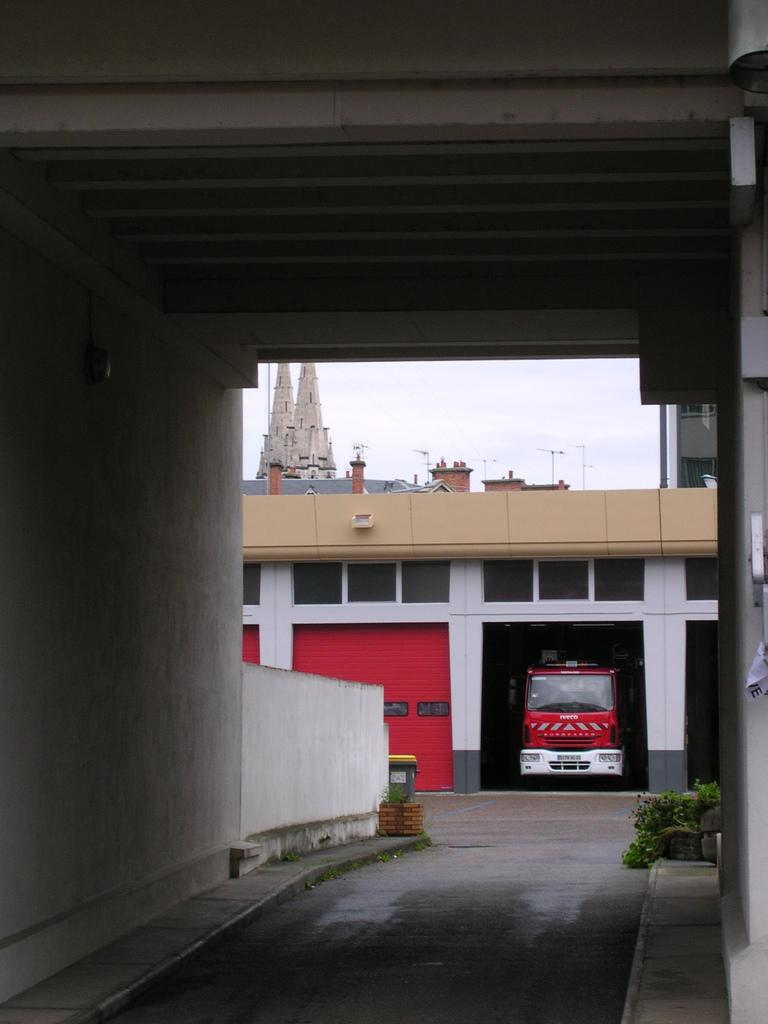What type of vehicle is in the garage in the image? There is a motor vehicle in the garage in the image. What type of doors are present in the garage? There are shutter doors in the image. What structure is visible in the image? There is a building in the image. What type of vegetation is present in the image? There are plants in the image. What type of street infrastructure is visible in the image? There are street poles in the image. What part of the natural environment is visible in the image? The sky is visible in the image. Can you see the person's toe in the image? There is no visible person or toe in the image. What type of shirt is hanging on the street pole in the image? There are no shirts present on the street poles in the image. 